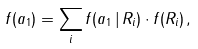<formula> <loc_0><loc_0><loc_500><loc_500>f ( a _ { 1 } ) = \sum _ { i } f ( a _ { 1 } \, | \, R _ { i } ) \cdot f ( R _ { i } ) \, ,</formula> 